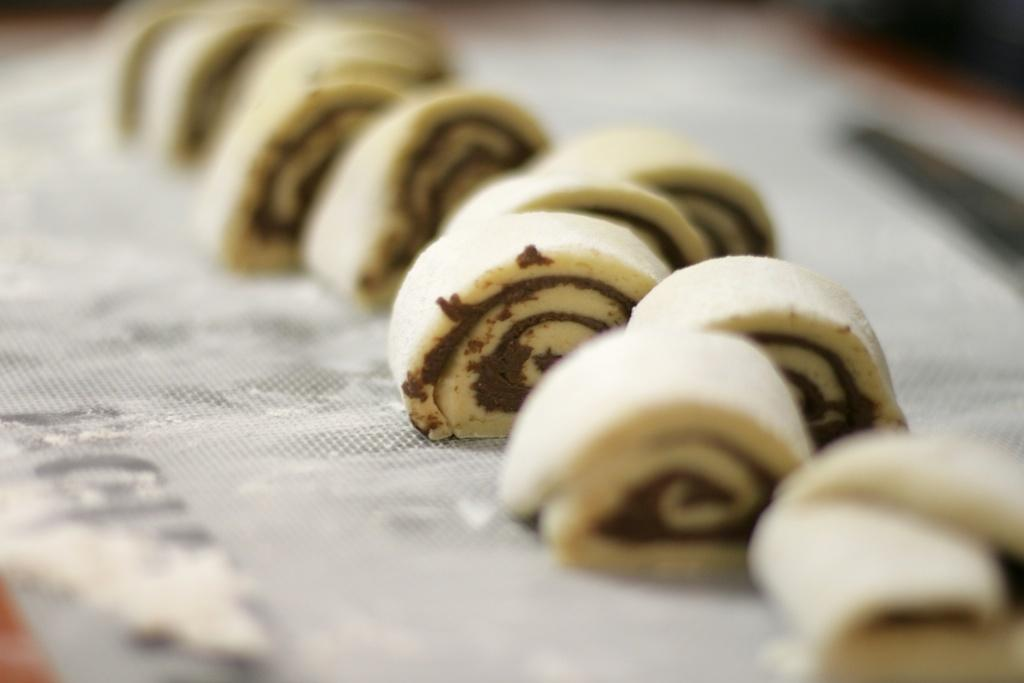What is the main subject of the image? There is a food item in the image. How is the food item presented? The food item is placed on a tray. Can you describe the background of the image? The background of the image is blurry. What is the price of the print on the food item in the image? There is no print or price mentioned in the image; it only shows a food item placed on a tray with a blurry background. 